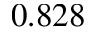Convert formula to latex. <formula><loc_0><loc_0><loc_500><loc_500>0 . 8 2 8</formula> 